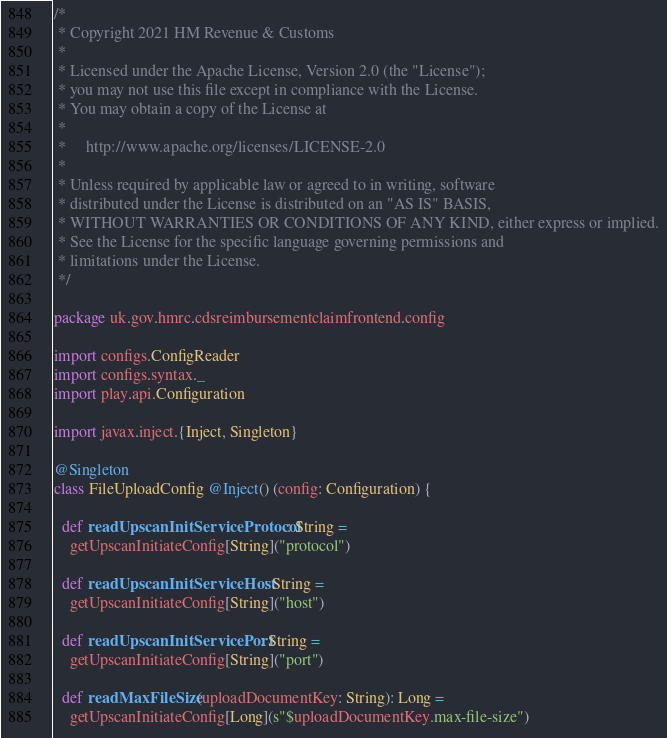<code> <loc_0><loc_0><loc_500><loc_500><_Scala_>/*
 * Copyright 2021 HM Revenue & Customs
 *
 * Licensed under the Apache License, Version 2.0 (the "License");
 * you may not use this file except in compliance with the License.
 * You may obtain a copy of the License at
 *
 *     http://www.apache.org/licenses/LICENSE-2.0
 *
 * Unless required by applicable law or agreed to in writing, software
 * distributed under the License is distributed on an "AS IS" BASIS,
 * WITHOUT WARRANTIES OR CONDITIONS OF ANY KIND, either express or implied.
 * See the License for the specific language governing permissions and
 * limitations under the License.
 */

package uk.gov.hmrc.cdsreimbursementclaimfrontend.config

import configs.ConfigReader
import configs.syntax._
import play.api.Configuration

import javax.inject.{Inject, Singleton}

@Singleton
class FileUploadConfig @Inject() (config: Configuration) {

  def readUpscanInitServiceProtocol: String =
    getUpscanInitiateConfig[String]("protocol")

  def readUpscanInitServiceHost: String =
    getUpscanInitiateConfig[String]("host")

  def readUpscanInitServicePort: String =
    getUpscanInitiateConfig[String]("port")

  def readMaxFileSize(uploadDocumentKey: String): Long =
    getUpscanInitiateConfig[Long](s"$uploadDocumentKey.max-file-size")
</code> 